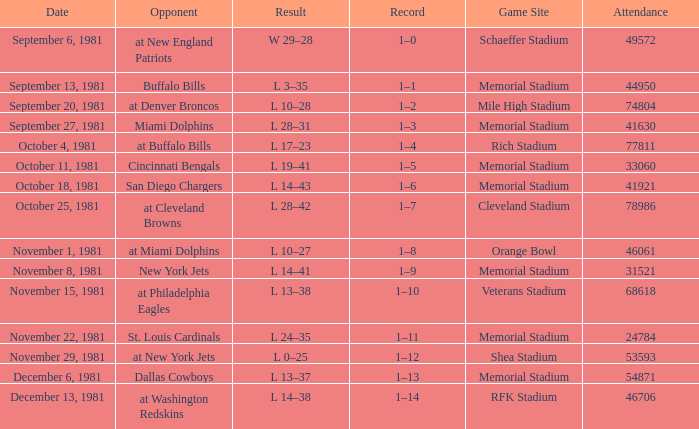Against whom was the competition on october 25, 1981? At cleveland browns. 